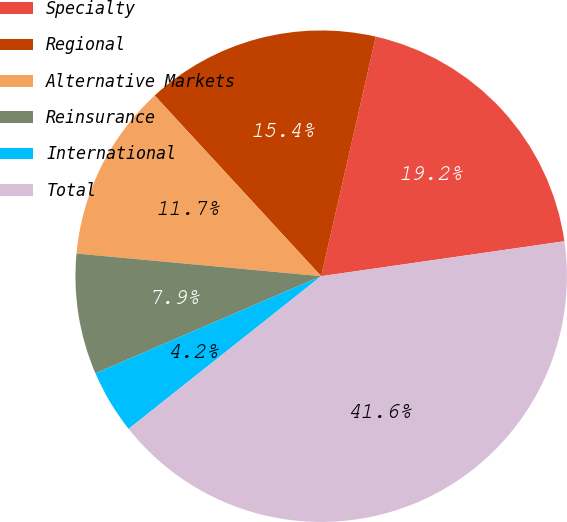Convert chart. <chart><loc_0><loc_0><loc_500><loc_500><pie_chart><fcel>Specialty<fcel>Regional<fcel>Alternative Markets<fcel>Reinsurance<fcel>International<fcel>Total<nl><fcel>19.16%<fcel>15.42%<fcel>11.68%<fcel>7.94%<fcel>4.2%<fcel>41.6%<nl></chart> 